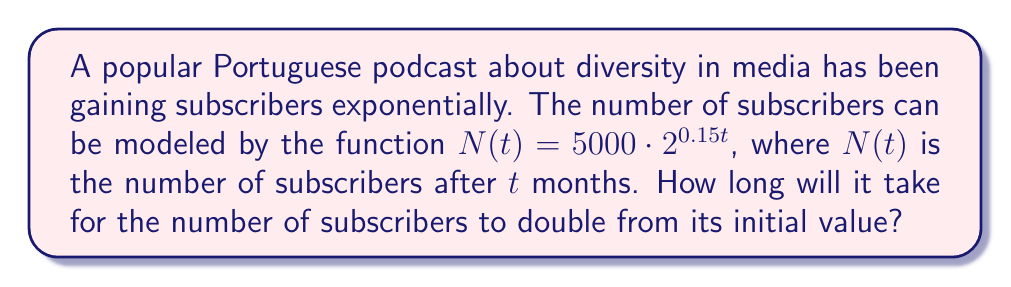Provide a solution to this math problem. To find the doubling time, we need to determine when $N(t)$ becomes twice the initial value:

1. Initial value: $N(0) = 5000 \cdot 2^{0.15 \cdot 0} = 5000$

2. We want to find $t$ when $N(t) = 2 \cdot 5000 = 10000$

3. Set up the equation:
   $10000 = 5000 \cdot 2^{0.15t}$

4. Divide both sides by 5000:
   $2 = 2^{0.15t}$

5. Take the logarithm (base 2) of both sides:
   $\log_2(2) = \log_2(2^{0.15t})$

6. Simplify:
   $1 = 0.15t \cdot \log_2(2) = 0.15t$

7. Solve for $t$:
   $t = \frac{1}{0.15} \approx 6.67$ months

Therefore, it will take approximately 6.67 months for the number of subscribers to double.
Answer: $\frac{1}{0.15} \approx 6.67$ months 